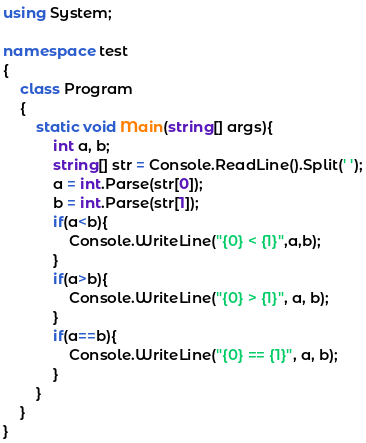Convert code to text. <code><loc_0><loc_0><loc_500><loc_500><_C#_>using System;

namespace test
{
    class Program
    {
        static void Main(string[] args){
            int a, b;
            string[] str = Console.ReadLine().Split(' ');
            a = int.Parse(str[0]);
            b = int.Parse(str[1]);
            if(a<b){
                Console.WriteLine("{0} < {1}",a,b);
            }
            if(a>b){
                Console.WriteLine("{0} > {1}", a, b);
            }
            if(a==b){
                Console.WriteLine("{0} == {1}", a, b);
            }
		}
    }
}</code> 